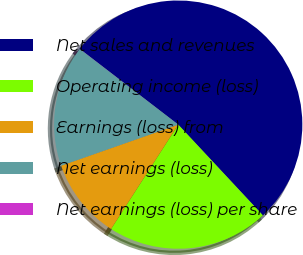Convert chart to OTSL. <chart><loc_0><loc_0><loc_500><loc_500><pie_chart><fcel>Net sales and revenues<fcel>Operating income (loss)<fcel>Earnings (loss) from<fcel>Net earnings (loss)<fcel>Net earnings (loss) per share<nl><fcel>52.62%<fcel>21.05%<fcel>10.53%<fcel>15.79%<fcel>0.01%<nl></chart> 